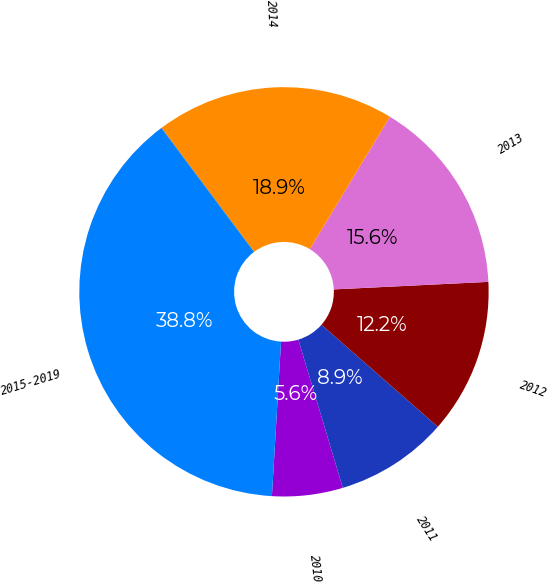Convert chart. <chart><loc_0><loc_0><loc_500><loc_500><pie_chart><fcel>2010<fcel>2011<fcel>2012<fcel>2013<fcel>2014<fcel>2015-2019<nl><fcel>5.58%<fcel>8.9%<fcel>12.23%<fcel>15.56%<fcel>18.88%<fcel>38.84%<nl></chart> 